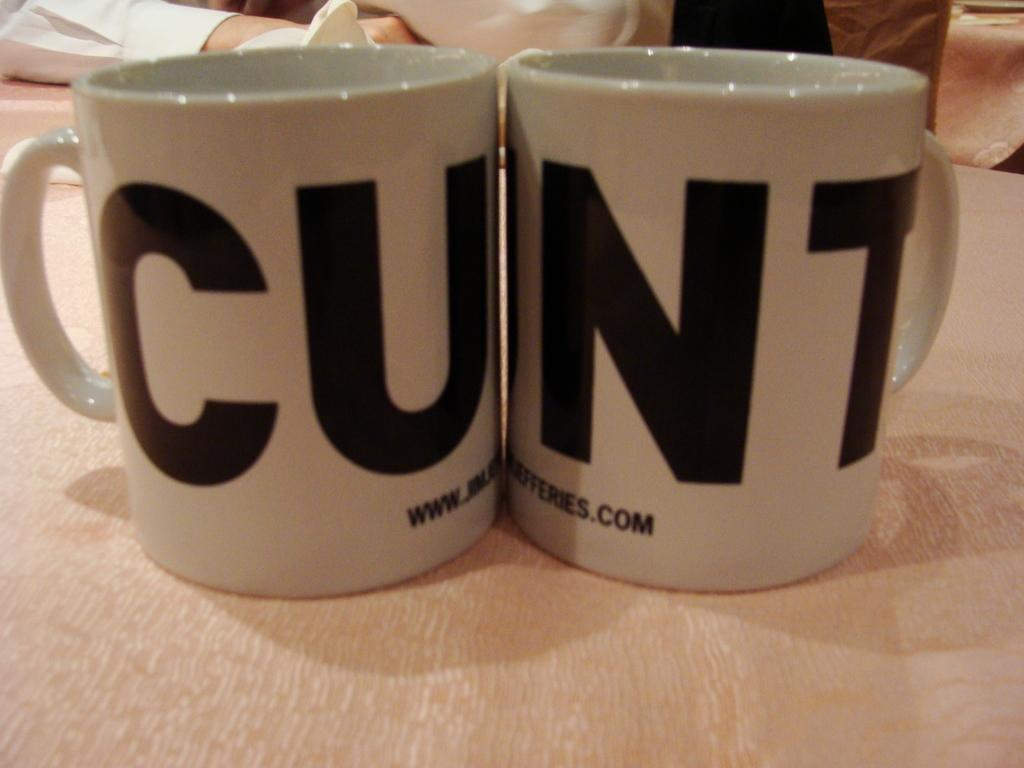<image>
Share a concise interpretation of the image provided. A pair of coffee mugs of which one says CU and the other says NT> 